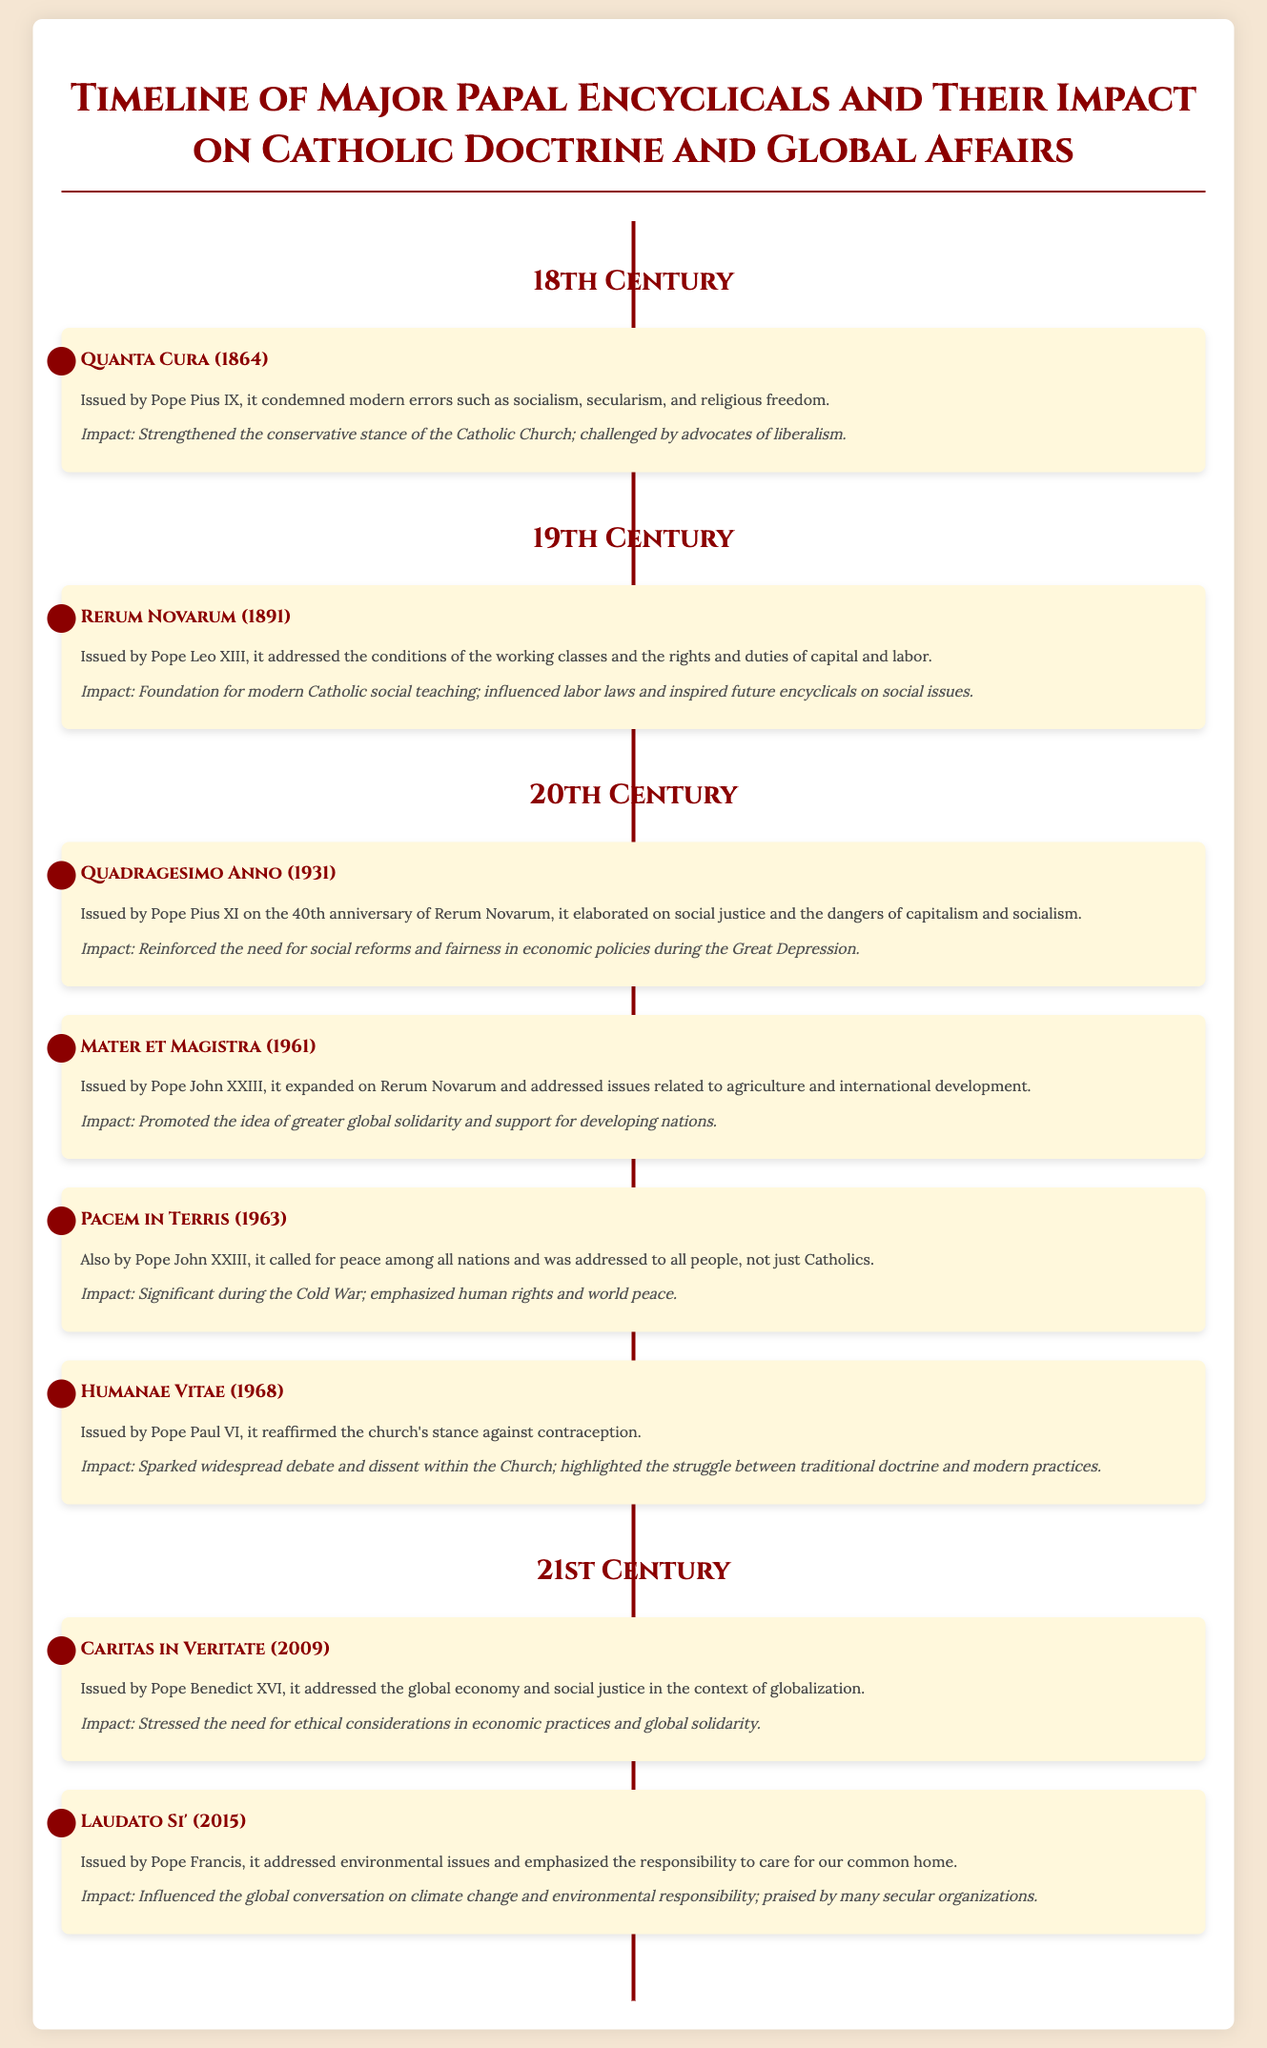What encyclical was issued by Pope Pius IX in 1864? The document lists "Quanta Cura (1864)" as the encyclical issued by Pope Pius IX.
Answer: Quanta Cura What was the impact of Rerum Novarum? The impact of Rerum Novarum is described as the foundation for modern Catholic social teaching and its influence on labor laws.
Answer: Foundation for modern Catholic social teaching Which encyclical addressed environmental issues? The document states that "Laudato Si' (2015)" issued by Pope Francis addressed environmental issues.
Answer: Laudato Si' Who issued Humanae Vitae? According to the document, "Humanae Vitae" was issued by Pope Paul VI.
Answer: Pope Paul VI What year was Pacem in Terris released? The timeline indicates that Pacem in Terris was released in 1963.
Answer: 1963 How many encyclicals are mentioned from the 20th century? The document lists four encyclicals from the 20th century.
Answer: Four Which encyclical calls for peace among all nations? The document states that "Pacem in Terris" calls for peace among all nations.
Answer: Pacem in Terris What common theme is present in Mater et Magistra and Caritas in Veritate? Both encyclicals address social issues and the rights/duties related to economic practices.
Answer: Social issues and economic practices 